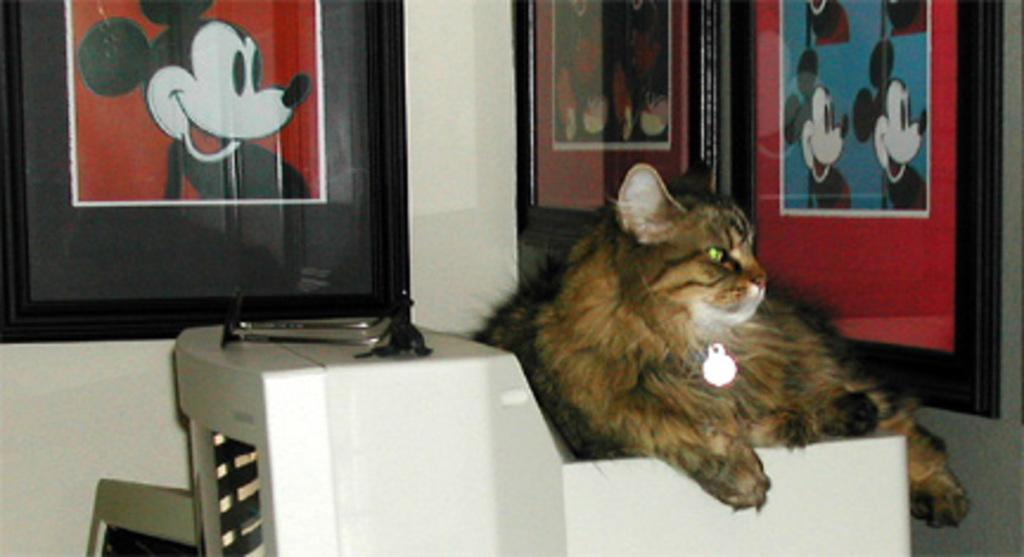What type of animal is in the image? There is a cat in the image. What is the cat wearing? The cat is wearing a chain with a light. Where is the cat sitting? The cat is sitting on a stand. What can be seen on the wall in the background of the image? There are frames on the wall in the background of the image. What activity is the cat participating in while wearing a crown in the image? There is no crown present in the image, and the cat is not participating in any activity. 